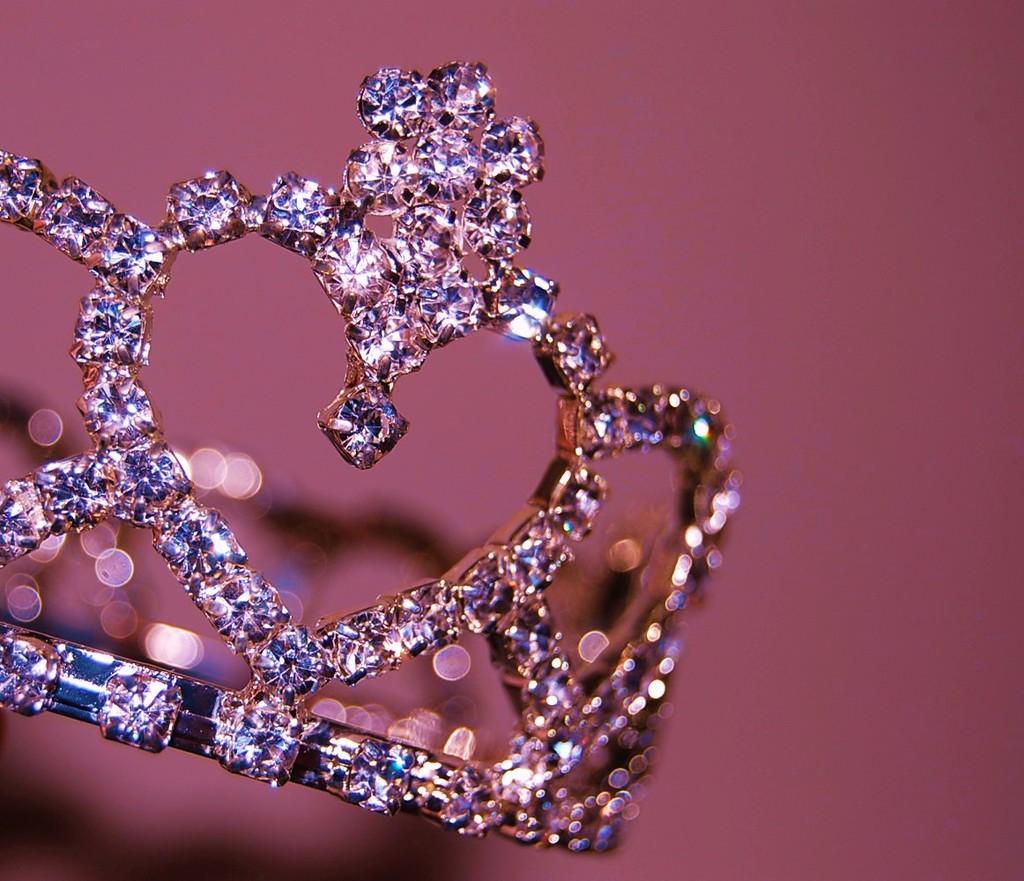Please provide a concise description of this image. In this image there is a crown, in the background it is blurred. 